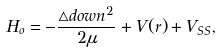Convert formula to latex. <formula><loc_0><loc_0><loc_500><loc_500>H _ { o } = - \frac { \triangle d o w n ^ { 2 } } { 2 \mu } + V ( r ) + V _ { S S } ,</formula> 